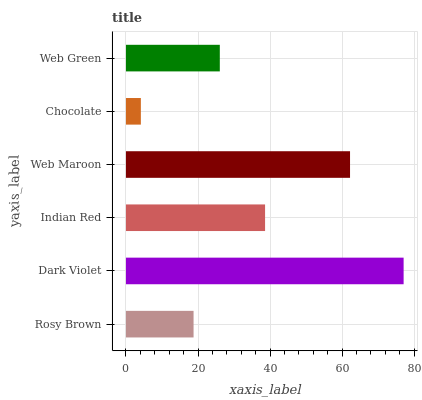Is Chocolate the minimum?
Answer yes or no. Yes. Is Dark Violet the maximum?
Answer yes or no. Yes. Is Indian Red the minimum?
Answer yes or no. No. Is Indian Red the maximum?
Answer yes or no. No. Is Dark Violet greater than Indian Red?
Answer yes or no. Yes. Is Indian Red less than Dark Violet?
Answer yes or no. Yes. Is Indian Red greater than Dark Violet?
Answer yes or no. No. Is Dark Violet less than Indian Red?
Answer yes or no. No. Is Indian Red the high median?
Answer yes or no. Yes. Is Web Green the low median?
Answer yes or no. Yes. Is Chocolate the high median?
Answer yes or no. No. Is Chocolate the low median?
Answer yes or no. No. 